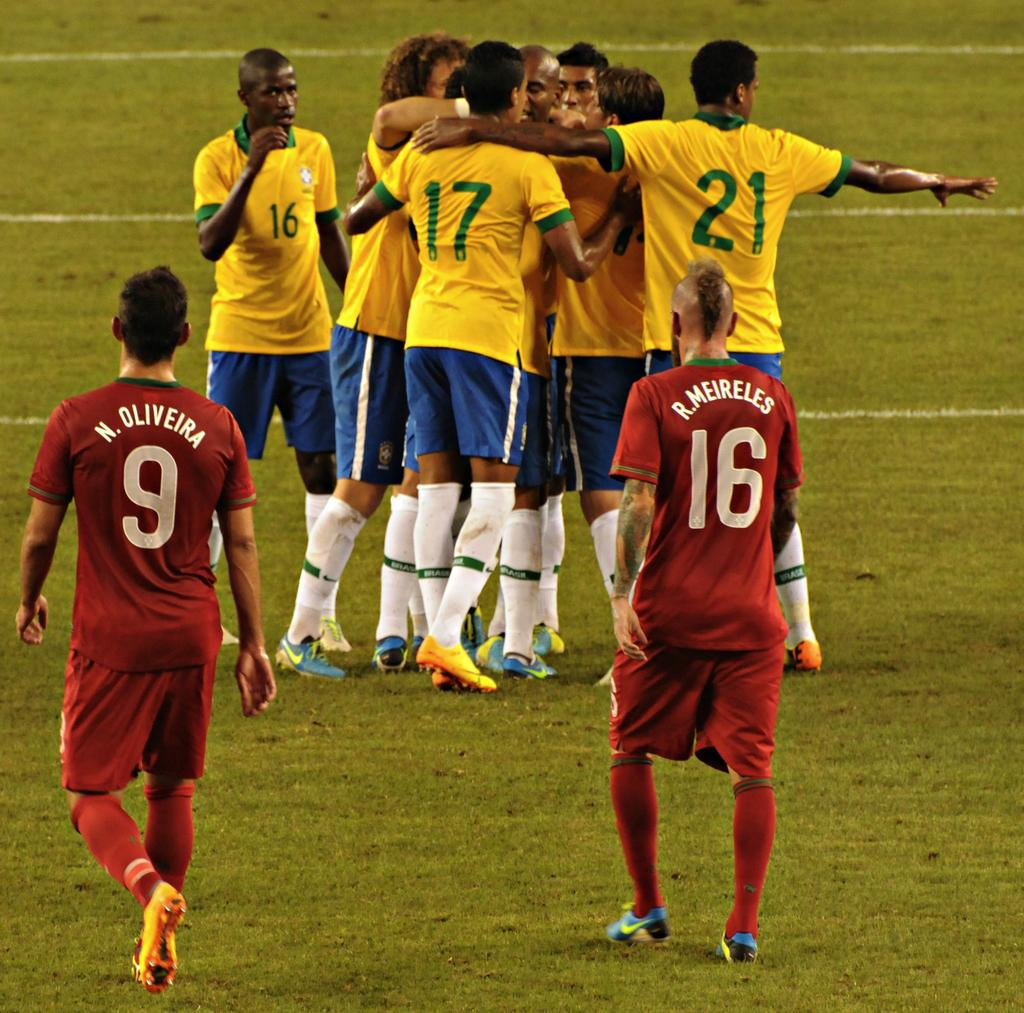<image>
Present a compact description of the photo's key features. sportsmen on a field hugging while opposing team members in numbered jerseys 9 and 16 look on 